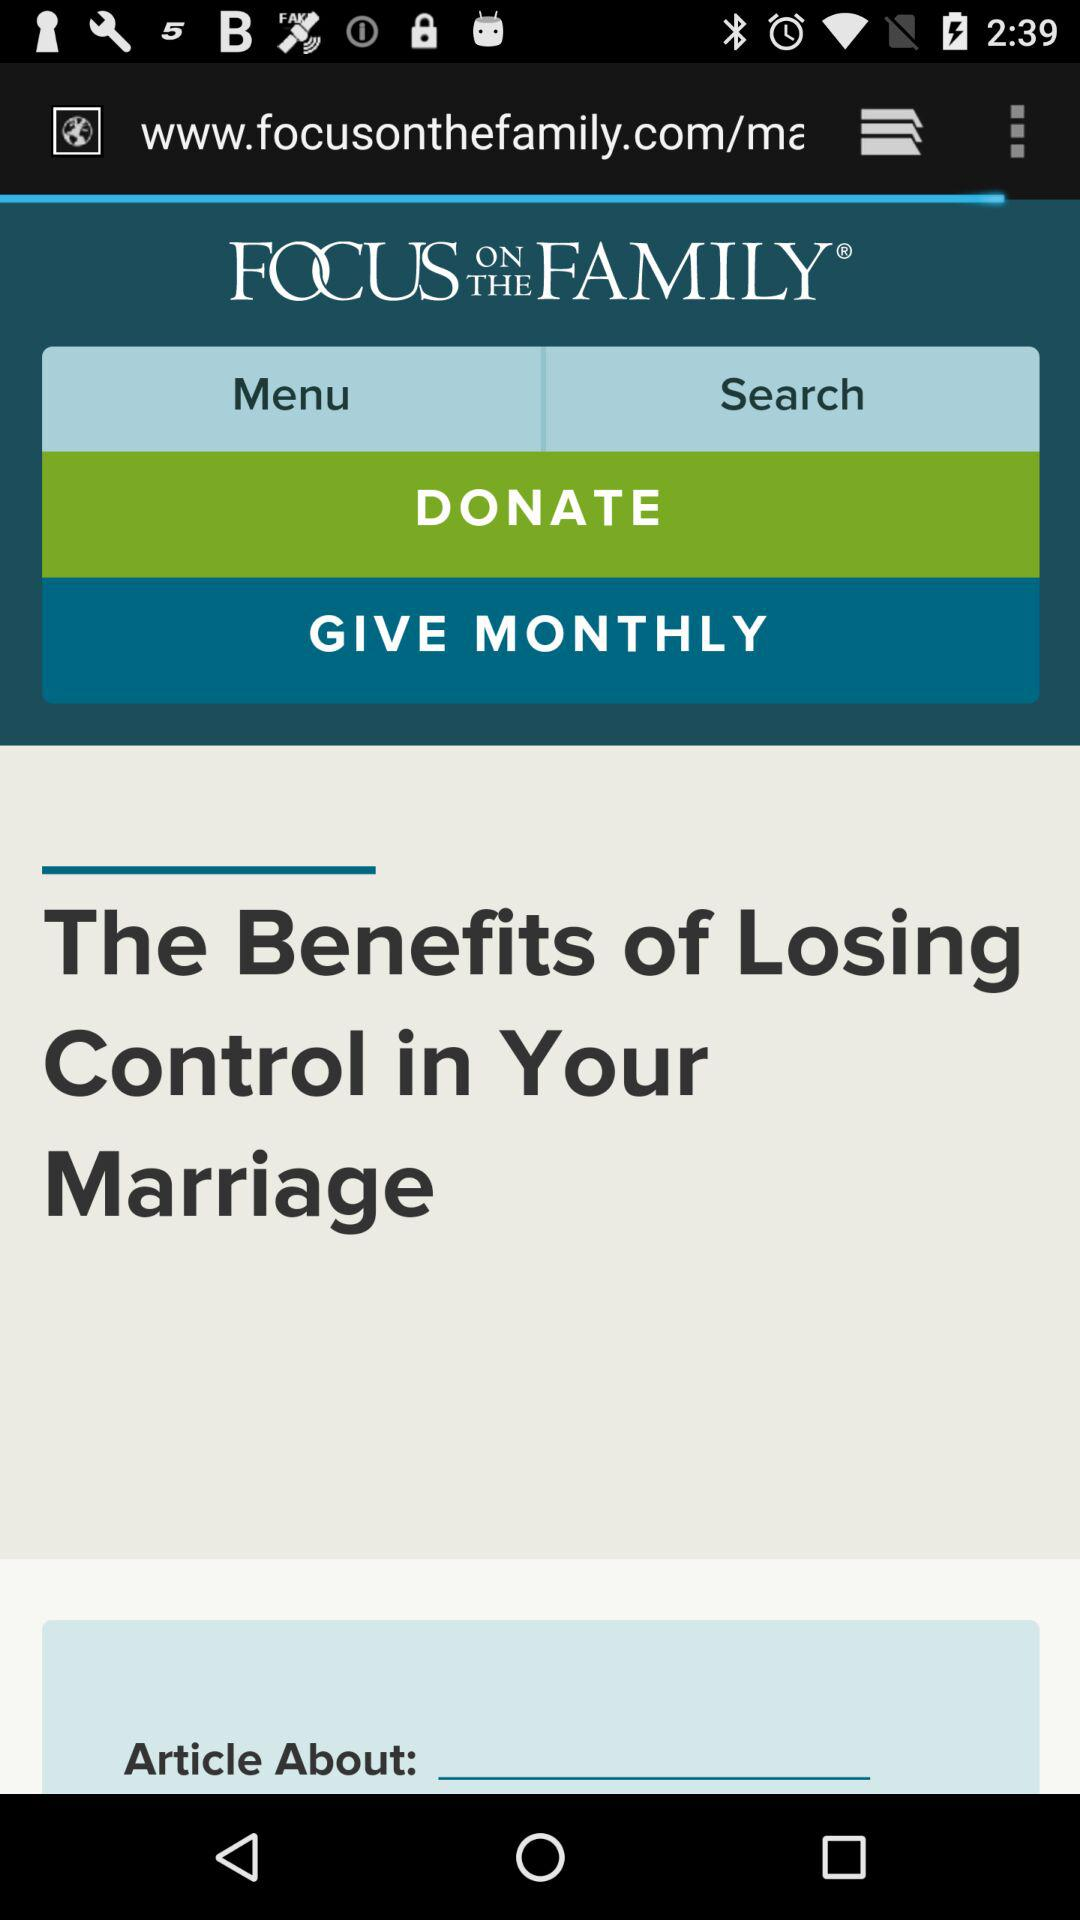What is the name of the application? The name of the application is "FOCUS ON THE FAMILY". 